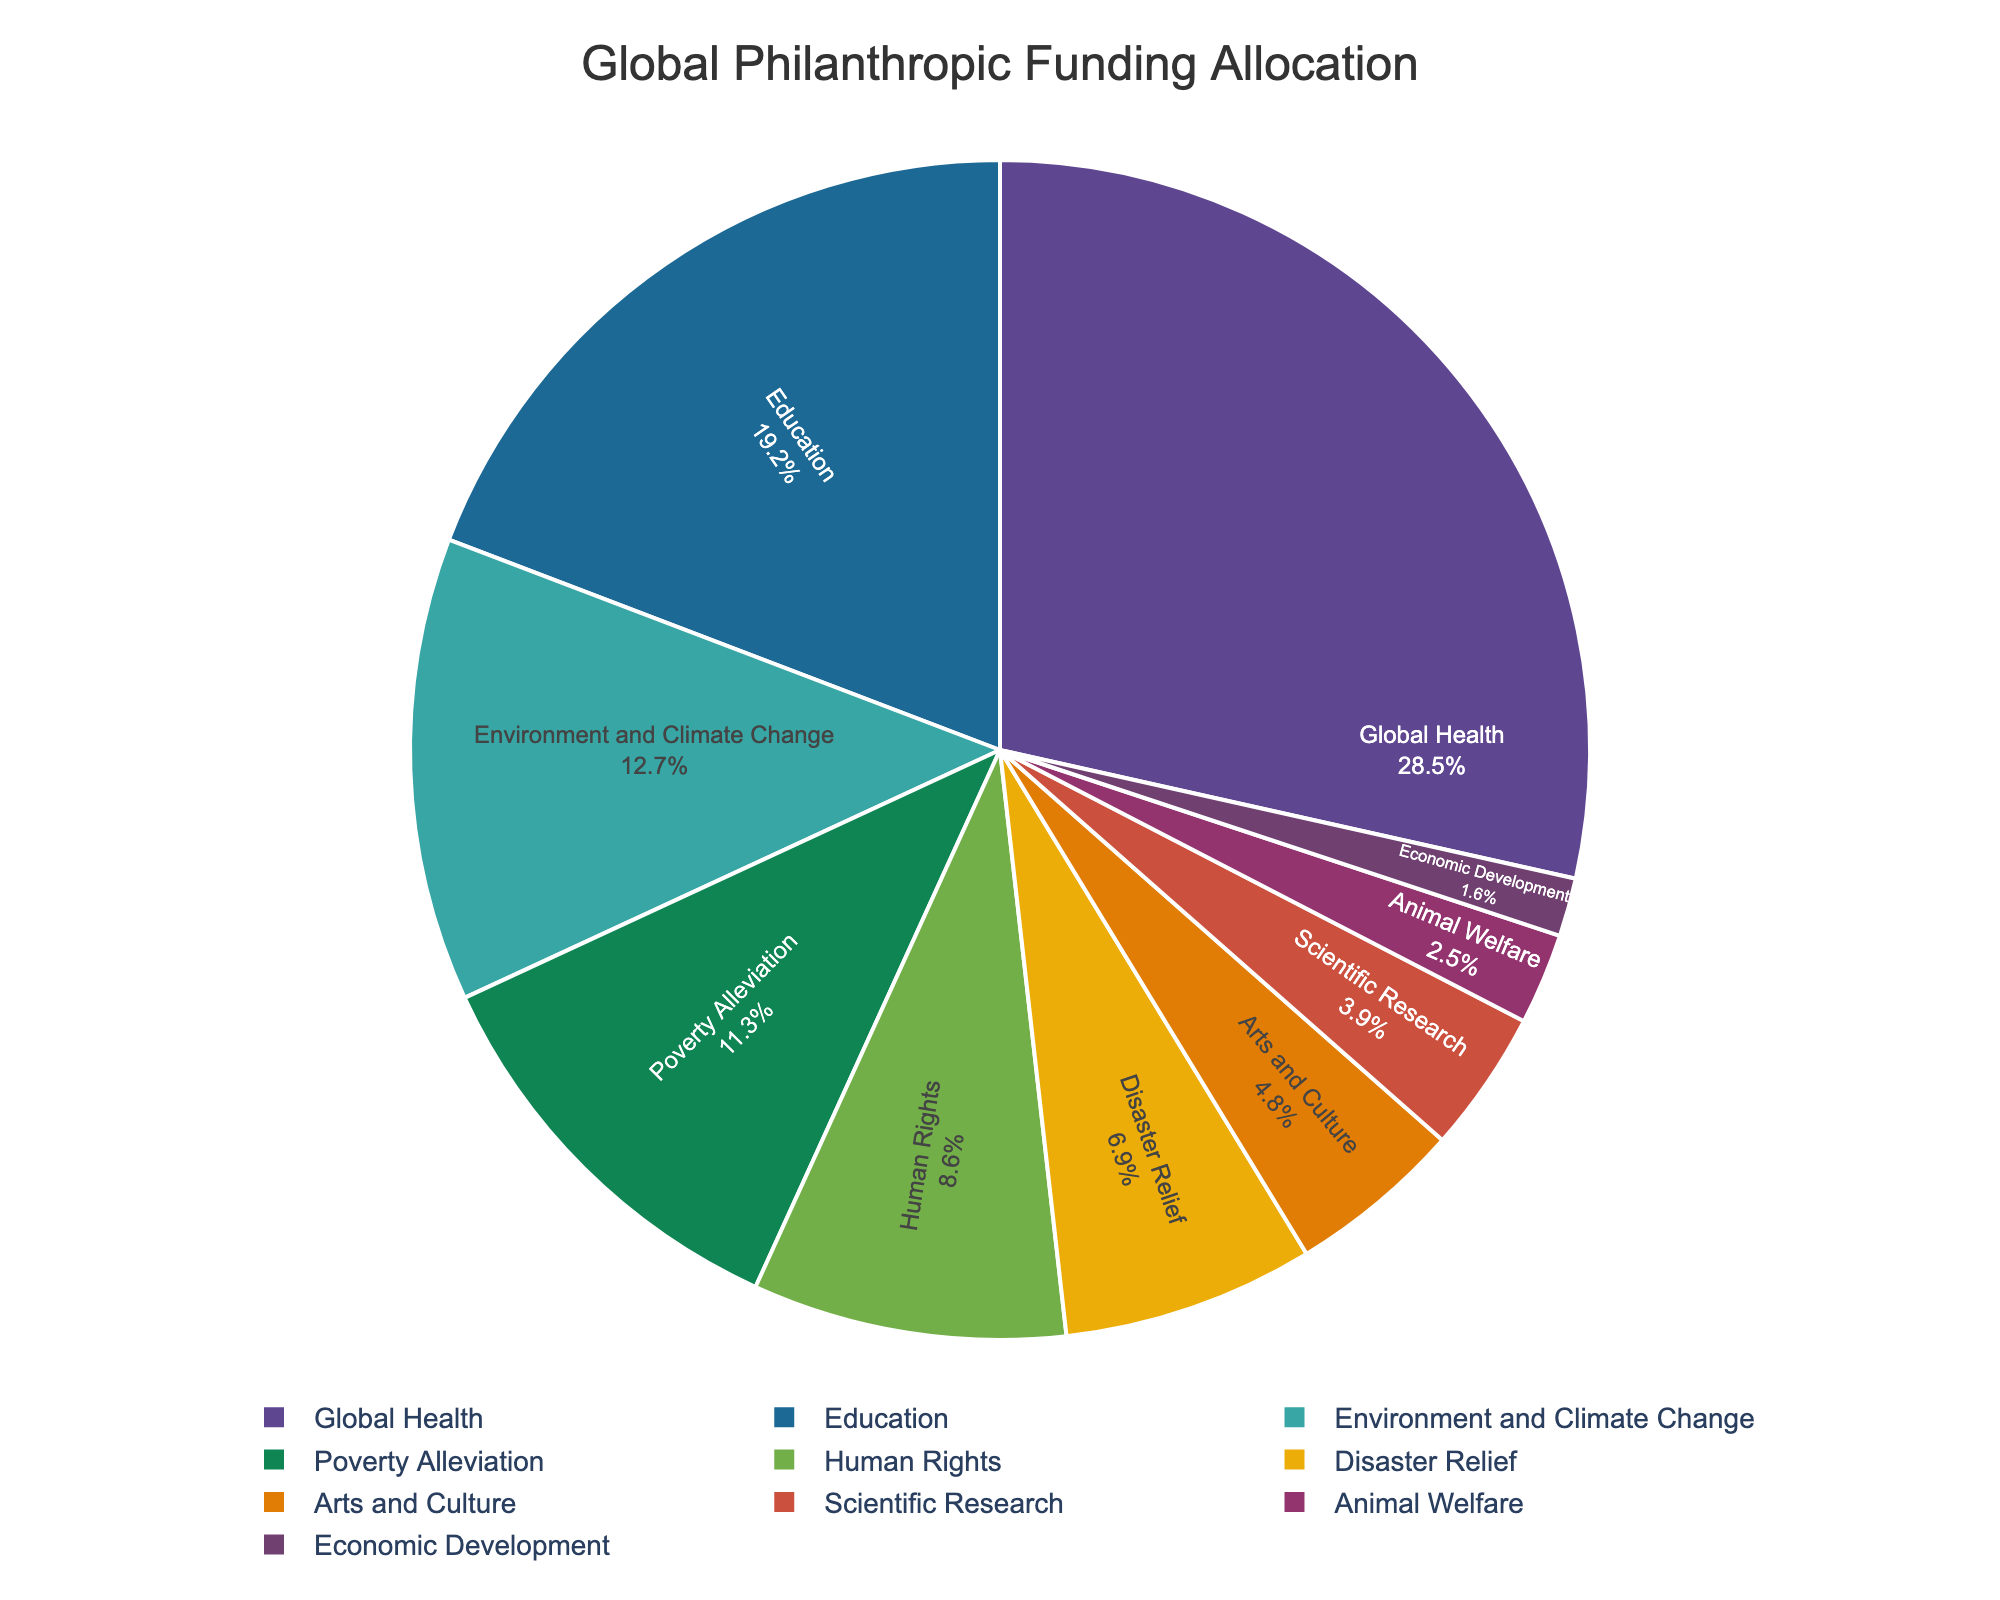What percentage of funding goes to Global Health? Locate the "Global Health" segment on the pie chart and read the label, which lists percentages.
Answer: 28.5% Which cause receives the least amount of funding? Identify the smallest segment in the pie chart and check the associated label for that cause.
Answer: Economic Development How much more funding does Education receive compared to Economic Development? Subtract Economic Development's percentage from Education's percentage: 19.2 - 1.6 = 17.6
Answer: 17.6% Which causes receive more than 10% of the total funding? Look for segments in the pie chart that have percentages greater than 10%. These are Global Health, Education, Environment and Climate Change, and Poverty Alleviation.
Answer: Global Health, Education, Environment and Climate Change, Poverty Alleviation What combined percentage of funding goes to Disaster Relief and Animal Welfare? Add the percentages for Disaster Relief and Animal Welfare: 6.9 + 2.5 = 9.4
Answer: 9.4% Is funding for Human Rights greater than funding for Scientific Research? Compare the percentages for Human Rights (8.6%) and Scientific Research (3.9%).
Answer: Yes Which cause receives funding closest to 5%? Identify the segment with a value closest to 5%. Arts and Culture receives 4.8%, which is the nearest.
Answer: Arts and Culture How much funding difference is there between Environmental and Climate Change and Poverty Alleviation? Subtract the percentage for Poverty Alleviation from that for Environment and Climate Change: 12.7 - 11.3 = 1.4
Answer: 1.4% Which causes have funding allocations greater than 15%? Look for segments with percentages greater than 15%, which are Global Health and Education.
Answer: Global Health, Education What is the total percentage of funding allocated to Poverty Alleviation, Scientific Research, and Animal Welfare? Add the percentages for the three causes: 11.3 + 3.9 + 2.5 = 17.7
Answer: 17.7% 